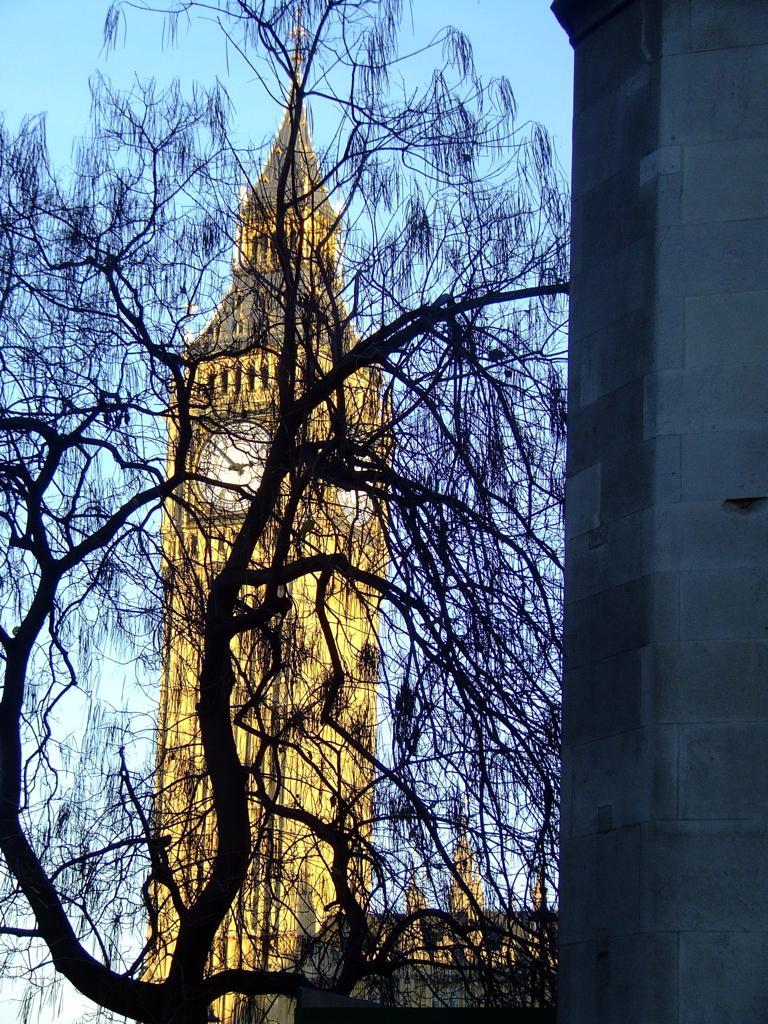Please provide a concise description of this image. In this image on the left side I can see the pillar. I can see the tree and the clock tower. In the background, I can see the sky. 